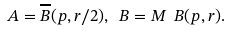<formula> <loc_0><loc_0><loc_500><loc_500>A = \overline { B } ( p , r / 2 ) , \ B = M \ B ( p , r ) .</formula> 